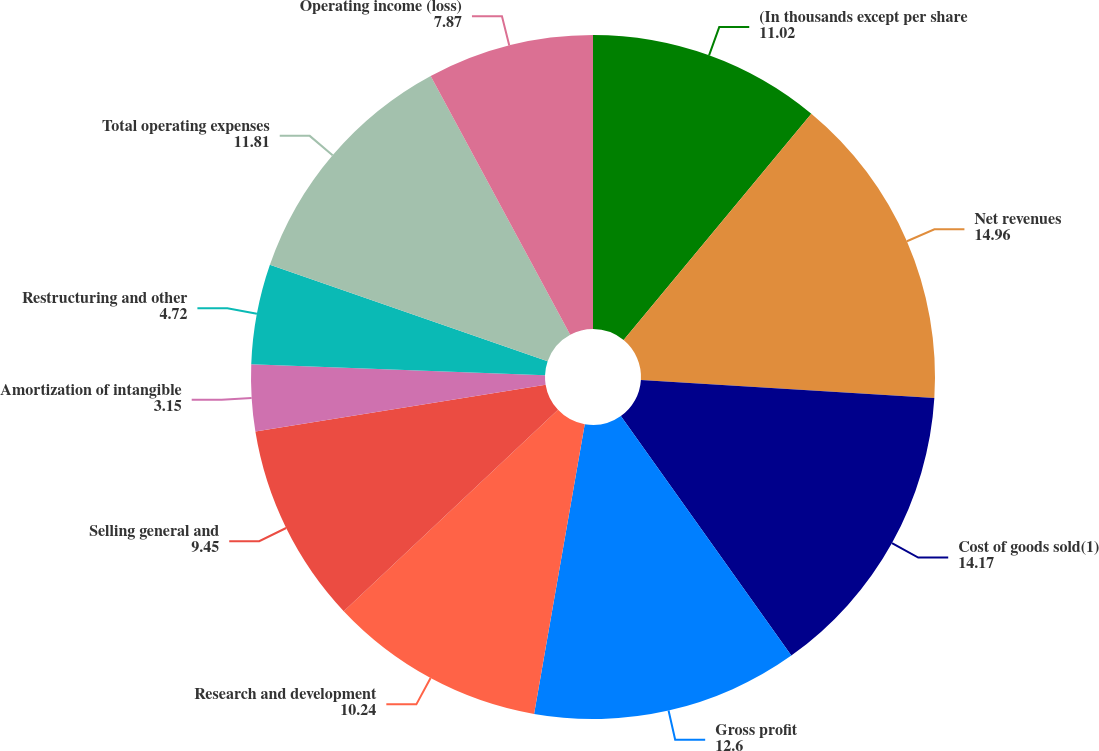<chart> <loc_0><loc_0><loc_500><loc_500><pie_chart><fcel>(In thousands except per share<fcel>Net revenues<fcel>Cost of goods sold(1)<fcel>Gross profit<fcel>Research and development<fcel>Selling general and<fcel>Amortization of intangible<fcel>Restructuring and other<fcel>Total operating expenses<fcel>Operating income (loss)<nl><fcel>11.02%<fcel>14.96%<fcel>14.17%<fcel>12.6%<fcel>10.24%<fcel>9.45%<fcel>3.15%<fcel>4.72%<fcel>11.81%<fcel>7.87%<nl></chart> 